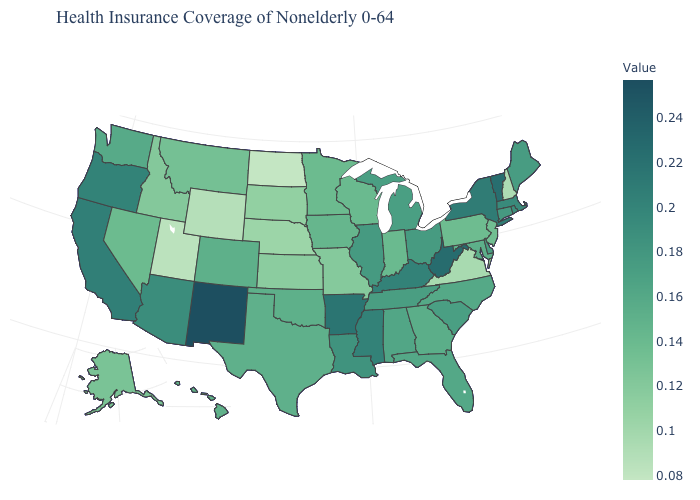Among the states that border Maryland , does West Virginia have the lowest value?
Write a very short answer. No. Does Louisiana have a lower value than New York?
Write a very short answer. Yes. Does North Dakota have the lowest value in the USA?
Concise answer only. Yes. Which states have the lowest value in the South?
Give a very brief answer. Virginia. Does Oregon have a lower value than Colorado?
Quick response, please. No. Does Tennessee have a lower value than Vermont?
Answer briefly. Yes. Among the states that border New Mexico , does Utah have the lowest value?
Write a very short answer. Yes. 